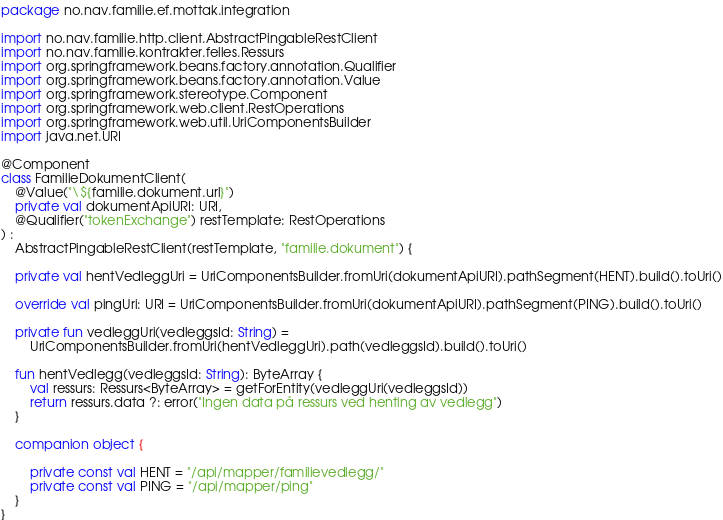<code> <loc_0><loc_0><loc_500><loc_500><_Kotlin_>package no.nav.familie.ef.mottak.integration

import no.nav.familie.http.client.AbstractPingableRestClient
import no.nav.familie.kontrakter.felles.Ressurs
import org.springframework.beans.factory.annotation.Qualifier
import org.springframework.beans.factory.annotation.Value
import org.springframework.stereotype.Component
import org.springframework.web.client.RestOperations
import org.springframework.web.util.UriComponentsBuilder
import java.net.URI

@Component
class FamilieDokumentClient(
    @Value("\${familie.dokument.url}")
    private val dokumentApiURI: URI,
    @Qualifier("tokenExchange") restTemplate: RestOperations
) :
    AbstractPingableRestClient(restTemplate, "familie.dokument") {

    private val hentVedleggUri = UriComponentsBuilder.fromUri(dokumentApiURI).pathSegment(HENT).build().toUri()

    override val pingUri: URI = UriComponentsBuilder.fromUri(dokumentApiURI).pathSegment(PING).build().toUri()

    private fun vedleggUri(vedleggsId: String) =
        UriComponentsBuilder.fromUri(hentVedleggUri).path(vedleggsId).build().toUri()

    fun hentVedlegg(vedleggsId: String): ByteArray {
        val ressurs: Ressurs<ByteArray> = getForEntity(vedleggUri(vedleggsId))
        return ressurs.data ?: error("Ingen data på ressurs ved henting av vedlegg")
    }

    companion object {

        private const val HENT = "/api/mapper/familievedlegg/"
        private const val PING = "/api/mapper/ping"
    }
}
</code> 